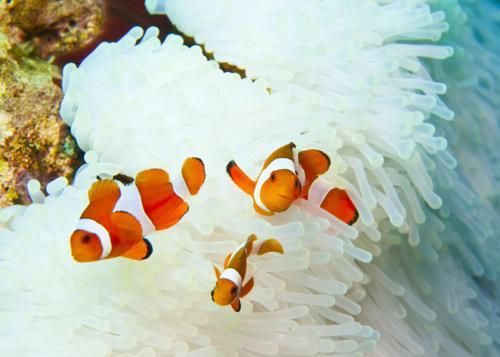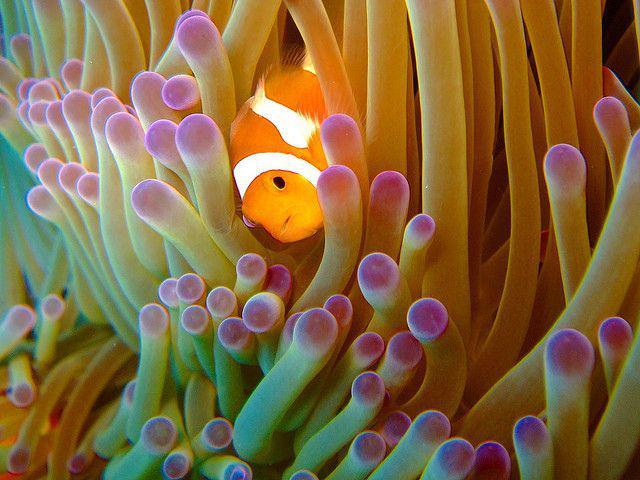The first image is the image on the left, the second image is the image on the right. For the images displayed, is the sentence "Each image shows one black-eyed clown fish within the white, slender tendrils of an anemone." factually correct? Answer yes or no. No. The first image is the image on the left, the second image is the image on the right. For the images displayed, is the sentence "the left and right image contains the same number of dogs clownfish." factually correct? Answer yes or no. No. 